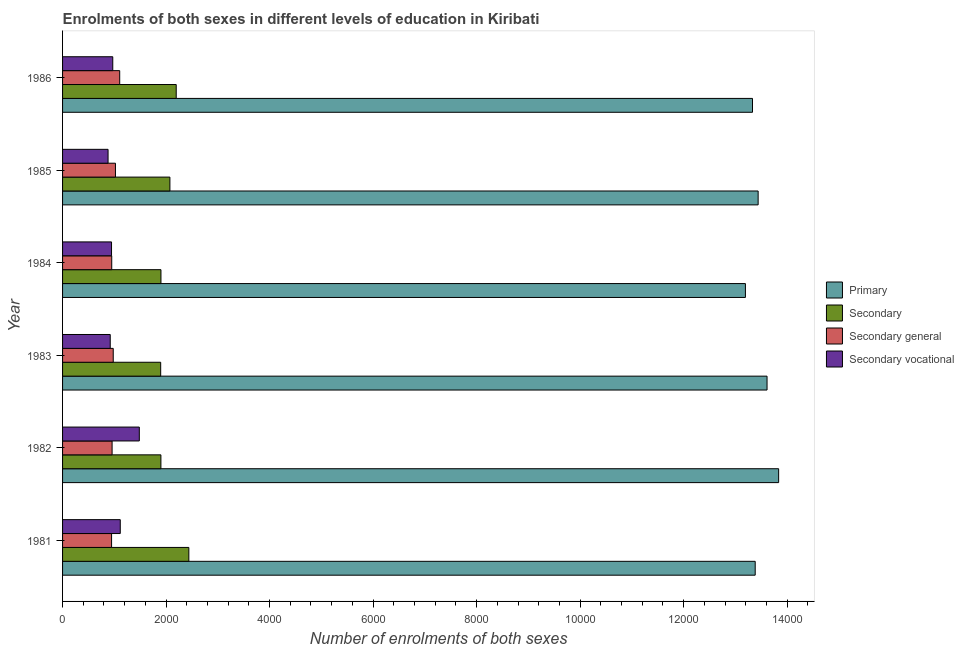How many different coloured bars are there?
Offer a very short reply. 4. How many bars are there on the 3rd tick from the bottom?
Ensure brevity in your answer.  4. In how many cases, is the number of bars for a given year not equal to the number of legend labels?
Your response must be concise. 0. What is the number of enrolments in secondary vocational education in 1981?
Your answer should be very brief. 1115. Across all years, what is the maximum number of enrolments in primary education?
Ensure brevity in your answer.  1.38e+04. Across all years, what is the minimum number of enrolments in secondary vocational education?
Provide a succinct answer. 879. What is the total number of enrolments in primary education in the graph?
Your answer should be very brief. 8.08e+04. What is the difference between the number of enrolments in secondary education in 1984 and that in 1985?
Your answer should be very brief. -173. What is the difference between the number of enrolments in primary education in 1982 and the number of enrolments in secondary education in 1986?
Offer a terse response. 1.16e+04. What is the average number of enrolments in secondary vocational education per year?
Your answer should be very brief. 1052.33. In the year 1986, what is the difference between the number of enrolments in primary education and number of enrolments in secondary education?
Make the answer very short. 1.11e+04. In how many years, is the number of enrolments in secondary education greater than 4400 ?
Your answer should be very brief. 0. What is the ratio of the number of enrolments in secondary education in 1985 to that in 1986?
Provide a succinct answer. 0.94. Is the number of enrolments in secondary education in 1984 less than that in 1986?
Keep it short and to the point. Yes. Is the difference between the number of enrolments in secondary general education in 1983 and 1985 greater than the difference between the number of enrolments in secondary education in 1983 and 1985?
Offer a terse response. Yes. What is the difference between the highest and the second highest number of enrolments in secondary education?
Offer a very short reply. 244. What is the difference between the highest and the lowest number of enrolments in secondary education?
Ensure brevity in your answer.  544. Is the sum of the number of enrolments in primary education in 1982 and 1984 greater than the maximum number of enrolments in secondary vocational education across all years?
Make the answer very short. Yes. Is it the case that in every year, the sum of the number of enrolments in secondary vocational education and number of enrolments in primary education is greater than the sum of number of enrolments in secondary education and number of enrolments in secondary general education?
Your answer should be very brief. Yes. What does the 3rd bar from the top in 1983 represents?
Provide a succinct answer. Secondary. What does the 3rd bar from the bottom in 1986 represents?
Your answer should be compact. Secondary general. How many years are there in the graph?
Offer a very short reply. 6. What is the difference between two consecutive major ticks on the X-axis?
Provide a succinct answer. 2000. What is the title of the graph?
Your answer should be very brief. Enrolments of both sexes in different levels of education in Kiribati. Does "Corruption" appear as one of the legend labels in the graph?
Ensure brevity in your answer.  No. What is the label or title of the X-axis?
Your answer should be compact. Number of enrolments of both sexes. What is the Number of enrolments of both sexes of Primary in 1981?
Ensure brevity in your answer.  1.34e+04. What is the Number of enrolments of both sexes of Secondary in 1981?
Make the answer very short. 2440. What is the Number of enrolments of both sexes in Secondary general in 1981?
Offer a very short reply. 947. What is the Number of enrolments of both sexes in Secondary vocational in 1981?
Provide a short and direct response. 1115. What is the Number of enrolments of both sexes of Primary in 1982?
Provide a succinct answer. 1.38e+04. What is the Number of enrolments of both sexes of Secondary in 1982?
Your answer should be very brief. 1900. What is the Number of enrolments of both sexes of Secondary general in 1982?
Provide a succinct answer. 957. What is the Number of enrolments of both sexes in Secondary vocational in 1982?
Offer a terse response. 1483. What is the Number of enrolments of both sexes in Primary in 1983?
Make the answer very short. 1.36e+04. What is the Number of enrolments of both sexes of Secondary in 1983?
Your answer should be very brief. 1896. What is the Number of enrolments of both sexes in Secondary general in 1983?
Your response must be concise. 979. What is the Number of enrolments of both sexes of Secondary vocational in 1983?
Your answer should be compact. 921. What is the Number of enrolments of both sexes of Primary in 1984?
Your response must be concise. 1.32e+04. What is the Number of enrolments of both sexes in Secondary in 1984?
Keep it short and to the point. 1901. What is the Number of enrolments of both sexes in Secondary general in 1984?
Offer a terse response. 950. What is the Number of enrolments of both sexes of Secondary vocational in 1984?
Provide a short and direct response. 946. What is the Number of enrolments of both sexes in Primary in 1985?
Provide a succinct answer. 1.34e+04. What is the Number of enrolments of both sexes in Secondary in 1985?
Offer a terse response. 2074. What is the Number of enrolments of both sexes of Secondary general in 1985?
Offer a terse response. 1022. What is the Number of enrolments of both sexes in Secondary vocational in 1985?
Give a very brief answer. 879. What is the Number of enrolments of both sexes of Primary in 1986?
Give a very brief answer. 1.33e+04. What is the Number of enrolments of both sexes of Secondary in 1986?
Provide a short and direct response. 2196. What is the Number of enrolments of both sexes of Secondary general in 1986?
Ensure brevity in your answer.  1104. What is the Number of enrolments of both sexes in Secondary vocational in 1986?
Keep it short and to the point. 970. Across all years, what is the maximum Number of enrolments of both sexes in Primary?
Your response must be concise. 1.38e+04. Across all years, what is the maximum Number of enrolments of both sexes of Secondary?
Offer a very short reply. 2440. Across all years, what is the maximum Number of enrolments of both sexes of Secondary general?
Offer a very short reply. 1104. Across all years, what is the maximum Number of enrolments of both sexes in Secondary vocational?
Keep it short and to the point. 1483. Across all years, what is the minimum Number of enrolments of both sexes in Primary?
Keep it short and to the point. 1.32e+04. Across all years, what is the minimum Number of enrolments of both sexes of Secondary?
Keep it short and to the point. 1896. Across all years, what is the minimum Number of enrolments of both sexes in Secondary general?
Give a very brief answer. 947. Across all years, what is the minimum Number of enrolments of both sexes of Secondary vocational?
Provide a short and direct response. 879. What is the total Number of enrolments of both sexes of Primary in the graph?
Ensure brevity in your answer.  8.08e+04. What is the total Number of enrolments of both sexes of Secondary in the graph?
Your response must be concise. 1.24e+04. What is the total Number of enrolments of both sexes in Secondary general in the graph?
Your response must be concise. 5959. What is the total Number of enrolments of both sexes of Secondary vocational in the graph?
Your response must be concise. 6314. What is the difference between the Number of enrolments of both sexes of Primary in 1981 and that in 1982?
Make the answer very short. -453. What is the difference between the Number of enrolments of both sexes in Secondary in 1981 and that in 1982?
Your answer should be very brief. 540. What is the difference between the Number of enrolments of both sexes in Secondary general in 1981 and that in 1982?
Offer a very short reply. -10. What is the difference between the Number of enrolments of both sexes of Secondary vocational in 1981 and that in 1982?
Provide a short and direct response. -368. What is the difference between the Number of enrolments of both sexes in Primary in 1981 and that in 1983?
Ensure brevity in your answer.  -229. What is the difference between the Number of enrolments of both sexes of Secondary in 1981 and that in 1983?
Offer a very short reply. 544. What is the difference between the Number of enrolments of both sexes of Secondary general in 1981 and that in 1983?
Offer a terse response. -32. What is the difference between the Number of enrolments of both sexes of Secondary vocational in 1981 and that in 1983?
Give a very brief answer. 194. What is the difference between the Number of enrolments of both sexes in Primary in 1981 and that in 1984?
Make the answer very short. 189. What is the difference between the Number of enrolments of both sexes of Secondary in 1981 and that in 1984?
Provide a succinct answer. 539. What is the difference between the Number of enrolments of both sexes of Secondary general in 1981 and that in 1984?
Your response must be concise. -3. What is the difference between the Number of enrolments of both sexes of Secondary vocational in 1981 and that in 1984?
Provide a succinct answer. 169. What is the difference between the Number of enrolments of both sexes of Primary in 1981 and that in 1985?
Your answer should be very brief. -57. What is the difference between the Number of enrolments of both sexes in Secondary in 1981 and that in 1985?
Give a very brief answer. 366. What is the difference between the Number of enrolments of both sexes of Secondary general in 1981 and that in 1985?
Provide a succinct answer. -75. What is the difference between the Number of enrolments of both sexes of Secondary vocational in 1981 and that in 1985?
Give a very brief answer. 236. What is the difference between the Number of enrolments of both sexes of Primary in 1981 and that in 1986?
Make the answer very short. 52. What is the difference between the Number of enrolments of both sexes in Secondary in 1981 and that in 1986?
Make the answer very short. 244. What is the difference between the Number of enrolments of both sexes of Secondary general in 1981 and that in 1986?
Your answer should be compact. -157. What is the difference between the Number of enrolments of both sexes of Secondary vocational in 1981 and that in 1986?
Give a very brief answer. 145. What is the difference between the Number of enrolments of both sexes of Primary in 1982 and that in 1983?
Your answer should be very brief. 224. What is the difference between the Number of enrolments of both sexes of Secondary general in 1982 and that in 1983?
Provide a short and direct response. -22. What is the difference between the Number of enrolments of both sexes in Secondary vocational in 1982 and that in 1983?
Offer a terse response. 562. What is the difference between the Number of enrolments of both sexes of Primary in 1982 and that in 1984?
Give a very brief answer. 642. What is the difference between the Number of enrolments of both sexes in Secondary vocational in 1982 and that in 1984?
Give a very brief answer. 537. What is the difference between the Number of enrolments of both sexes of Primary in 1982 and that in 1985?
Offer a very short reply. 396. What is the difference between the Number of enrolments of both sexes of Secondary in 1982 and that in 1985?
Ensure brevity in your answer.  -174. What is the difference between the Number of enrolments of both sexes of Secondary general in 1982 and that in 1985?
Make the answer very short. -65. What is the difference between the Number of enrolments of both sexes of Secondary vocational in 1982 and that in 1985?
Keep it short and to the point. 604. What is the difference between the Number of enrolments of both sexes of Primary in 1982 and that in 1986?
Ensure brevity in your answer.  505. What is the difference between the Number of enrolments of both sexes of Secondary in 1982 and that in 1986?
Your answer should be compact. -296. What is the difference between the Number of enrolments of both sexes in Secondary general in 1982 and that in 1986?
Keep it short and to the point. -147. What is the difference between the Number of enrolments of both sexes of Secondary vocational in 1982 and that in 1986?
Ensure brevity in your answer.  513. What is the difference between the Number of enrolments of both sexes of Primary in 1983 and that in 1984?
Make the answer very short. 418. What is the difference between the Number of enrolments of both sexes of Secondary in 1983 and that in 1984?
Give a very brief answer. -5. What is the difference between the Number of enrolments of both sexes in Secondary vocational in 1983 and that in 1984?
Provide a succinct answer. -25. What is the difference between the Number of enrolments of both sexes of Primary in 1983 and that in 1985?
Ensure brevity in your answer.  172. What is the difference between the Number of enrolments of both sexes in Secondary in 1983 and that in 1985?
Offer a very short reply. -178. What is the difference between the Number of enrolments of both sexes in Secondary general in 1983 and that in 1985?
Ensure brevity in your answer.  -43. What is the difference between the Number of enrolments of both sexes in Primary in 1983 and that in 1986?
Provide a short and direct response. 281. What is the difference between the Number of enrolments of both sexes of Secondary in 1983 and that in 1986?
Offer a terse response. -300. What is the difference between the Number of enrolments of both sexes in Secondary general in 1983 and that in 1986?
Offer a very short reply. -125. What is the difference between the Number of enrolments of both sexes in Secondary vocational in 1983 and that in 1986?
Your response must be concise. -49. What is the difference between the Number of enrolments of both sexes of Primary in 1984 and that in 1985?
Offer a terse response. -246. What is the difference between the Number of enrolments of both sexes of Secondary in 1984 and that in 1985?
Provide a succinct answer. -173. What is the difference between the Number of enrolments of both sexes of Secondary general in 1984 and that in 1985?
Offer a terse response. -72. What is the difference between the Number of enrolments of both sexes in Primary in 1984 and that in 1986?
Provide a succinct answer. -137. What is the difference between the Number of enrolments of both sexes in Secondary in 1984 and that in 1986?
Offer a terse response. -295. What is the difference between the Number of enrolments of both sexes of Secondary general in 1984 and that in 1986?
Keep it short and to the point. -154. What is the difference between the Number of enrolments of both sexes of Secondary vocational in 1984 and that in 1986?
Make the answer very short. -24. What is the difference between the Number of enrolments of both sexes of Primary in 1985 and that in 1986?
Your answer should be very brief. 109. What is the difference between the Number of enrolments of both sexes in Secondary in 1985 and that in 1986?
Your answer should be very brief. -122. What is the difference between the Number of enrolments of both sexes in Secondary general in 1985 and that in 1986?
Make the answer very short. -82. What is the difference between the Number of enrolments of both sexes in Secondary vocational in 1985 and that in 1986?
Your answer should be compact. -91. What is the difference between the Number of enrolments of both sexes of Primary in 1981 and the Number of enrolments of both sexes of Secondary in 1982?
Your response must be concise. 1.15e+04. What is the difference between the Number of enrolments of both sexes in Primary in 1981 and the Number of enrolments of both sexes in Secondary general in 1982?
Offer a very short reply. 1.24e+04. What is the difference between the Number of enrolments of both sexes of Primary in 1981 and the Number of enrolments of both sexes of Secondary vocational in 1982?
Provide a short and direct response. 1.19e+04. What is the difference between the Number of enrolments of both sexes of Secondary in 1981 and the Number of enrolments of both sexes of Secondary general in 1982?
Your answer should be compact. 1483. What is the difference between the Number of enrolments of both sexes of Secondary in 1981 and the Number of enrolments of both sexes of Secondary vocational in 1982?
Provide a short and direct response. 957. What is the difference between the Number of enrolments of both sexes of Secondary general in 1981 and the Number of enrolments of both sexes of Secondary vocational in 1982?
Keep it short and to the point. -536. What is the difference between the Number of enrolments of both sexes in Primary in 1981 and the Number of enrolments of both sexes in Secondary in 1983?
Your answer should be very brief. 1.15e+04. What is the difference between the Number of enrolments of both sexes of Primary in 1981 and the Number of enrolments of both sexes of Secondary general in 1983?
Offer a terse response. 1.24e+04. What is the difference between the Number of enrolments of both sexes of Primary in 1981 and the Number of enrolments of both sexes of Secondary vocational in 1983?
Give a very brief answer. 1.25e+04. What is the difference between the Number of enrolments of both sexes of Secondary in 1981 and the Number of enrolments of both sexes of Secondary general in 1983?
Give a very brief answer. 1461. What is the difference between the Number of enrolments of both sexes of Secondary in 1981 and the Number of enrolments of both sexes of Secondary vocational in 1983?
Make the answer very short. 1519. What is the difference between the Number of enrolments of both sexes of Secondary general in 1981 and the Number of enrolments of both sexes of Secondary vocational in 1983?
Make the answer very short. 26. What is the difference between the Number of enrolments of both sexes of Primary in 1981 and the Number of enrolments of both sexes of Secondary in 1984?
Offer a very short reply. 1.15e+04. What is the difference between the Number of enrolments of both sexes in Primary in 1981 and the Number of enrolments of both sexes in Secondary general in 1984?
Provide a short and direct response. 1.24e+04. What is the difference between the Number of enrolments of both sexes in Primary in 1981 and the Number of enrolments of both sexes in Secondary vocational in 1984?
Provide a succinct answer. 1.24e+04. What is the difference between the Number of enrolments of both sexes in Secondary in 1981 and the Number of enrolments of both sexes in Secondary general in 1984?
Offer a very short reply. 1490. What is the difference between the Number of enrolments of both sexes of Secondary in 1981 and the Number of enrolments of both sexes of Secondary vocational in 1984?
Your response must be concise. 1494. What is the difference between the Number of enrolments of both sexes in Secondary general in 1981 and the Number of enrolments of both sexes in Secondary vocational in 1984?
Keep it short and to the point. 1. What is the difference between the Number of enrolments of both sexes in Primary in 1981 and the Number of enrolments of both sexes in Secondary in 1985?
Your answer should be compact. 1.13e+04. What is the difference between the Number of enrolments of both sexes of Primary in 1981 and the Number of enrolments of both sexes of Secondary general in 1985?
Your answer should be very brief. 1.24e+04. What is the difference between the Number of enrolments of both sexes in Primary in 1981 and the Number of enrolments of both sexes in Secondary vocational in 1985?
Offer a terse response. 1.25e+04. What is the difference between the Number of enrolments of both sexes in Secondary in 1981 and the Number of enrolments of both sexes in Secondary general in 1985?
Keep it short and to the point. 1418. What is the difference between the Number of enrolments of both sexes in Secondary in 1981 and the Number of enrolments of both sexes in Secondary vocational in 1985?
Make the answer very short. 1561. What is the difference between the Number of enrolments of both sexes of Primary in 1981 and the Number of enrolments of both sexes of Secondary in 1986?
Provide a short and direct response. 1.12e+04. What is the difference between the Number of enrolments of both sexes in Primary in 1981 and the Number of enrolments of both sexes in Secondary general in 1986?
Give a very brief answer. 1.23e+04. What is the difference between the Number of enrolments of both sexes of Primary in 1981 and the Number of enrolments of both sexes of Secondary vocational in 1986?
Your response must be concise. 1.24e+04. What is the difference between the Number of enrolments of both sexes of Secondary in 1981 and the Number of enrolments of both sexes of Secondary general in 1986?
Offer a very short reply. 1336. What is the difference between the Number of enrolments of both sexes in Secondary in 1981 and the Number of enrolments of both sexes in Secondary vocational in 1986?
Keep it short and to the point. 1470. What is the difference between the Number of enrolments of both sexes of Primary in 1982 and the Number of enrolments of both sexes of Secondary in 1983?
Provide a short and direct response. 1.19e+04. What is the difference between the Number of enrolments of both sexes in Primary in 1982 and the Number of enrolments of both sexes in Secondary general in 1983?
Make the answer very short. 1.29e+04. What is the difference between the Number of enrolments of both sexes in Primary in 1982 and the Number of enrolments of both sexes in Secondary vocational in 1983?
Keep it short and to the point. 1.29e+04. What is the difference between the Number of enrolments of both sexes of Secondary in 1982 and the Number of enrolments of both sexes of Secondary general in 1983?
Ensure brevity in your answer.  921. What is the difference between the Number of enrolments of both sexes in Secondary in 1982 and the Number of enrolments of both sexes in Secondary vocational in 1983?
Offer a terse response. 979. What is the difference between the Number of enrolments of both sexes of Primary in 1982 and the Number of enrolments of both sexes of Secondary in 1984?
Keep it short and to the point. 1.19e+04. What is the difference between the Number of enrolments of both sexes in Primary in 1982 and the Number of enrolments of both sexes in Secondary general in 1984?
Provide a succinct answer. 1.29e+04. What is the difference between the Number of enrolments of both sexes in Primary in 1982 and the Number of enrolments of both sexes in Secondary vocational in 1984?
Provide a succinct answer. 1.29e+04. What is the difference between the Number of enrolments of both sexes in Secondary in 1982 and the Number of enrolments of both sexes in Secondary general in 1984?
Give a very brief answer. 950. What is the difference between the Number of enrolments of both sexes in Secondary in 1982 and the Number of enrolments of both sexes in Secondary vocational in 1984?
Make the answer very short. 954. What is the difference between the Number of enrolments of both sexes in Secondary general in 1982 and the Number of enrolments of both sexes in Secondary vocational in 1984?
Offer a terse response. 11. What is the difference between the Number of enrolments of both sexes of Primary in 1982 and the Number of enrolments of both sexes of Secondary in 1985?
Offer a very short reply. 1.18e+04. What is the difference between the Number of enrolments of both sexes of Primary in 1982 and the Number of enrolments of both sexes of Secondary general in 1985?
Offer a very short reply. 1.28e+04. What is the difference between the Number of enrolments of both sexes of Primary in 1982 and the Number of enrolments of both sexes of Secondary vocational in 1985?
Ensure brevity in your answer.  1.30e+04. What is the difference between the Number of enrolments of both sexes in Secondary in 1982 and the Number of enrolments of both sexes in Secondary general in 1985?
Ensure brevity in your answer.  878. What is the difference between the Number of enrolments of both sexes in Secondary in 1982 and the Number of enrolments of both sexes in Secondary vocational in 1985?
Your answer should be very brief. 1021. What is the difference between the Number of enrolments of both sexes of Secondary general in 1982 and the Number of enrolments of both sexes of Secondary vocational in 1985?
Your answer should be compact. 78. What is the difference between the Number of enrolments of both sexes in Primary in 1982 and the Number of enrolments of both sexes in Secondary in 1986?
Keep it short and to the point. 1.16e+04. What is the difference between the Number of enrolments of both sexes in Primary in 1982 and the Number of enrolments of both sexes in Secondary general in 1986?
Your response must be concise. 1.27e+04. What is the difference between the Number of enrolments of both sexes in Primary in 1982 and the Number of enrolments of both sexes in Secondary vocational in 1986?
Your answer should be compact. 1.29e+04. What is the difference between the Number of enrolments of both sexes in Secondary in 1982 and the Number of enrolments of both sexes in Secondary general in 1986?
Ensure brevity in your answer.  796. What is the difference between the Number of enrolments of both sexes in Secondary in 1982 and the Number of enrolments of both sexes in Secondary vocational in 1986?
Give a very brief answer. 930. What is the difference between the Number of enrolments of both sexes in Primary in 1983 and the Number of enrolments of both sexes in Secondary in 1984?
Keep it short and to the point. 1.17e+04. What is the difference between the Number of enrolments of both sexes of Primary in 1983 and the Number of enrolments of both sexes of Secondary general in 1984?
Provide a succinct answer. 1.27e+04. What is the difference between the Number of enrolments of both sexes in Primary in 1983 and the Number of enrolments of both sexes in Secondary vocational in 1984?
Provide a short and direct response. 1.27e+04. What is the difference between the Number of enrolments of both sexes of Secondary in 1983 and the Number of enrolments of both sexes of Secondary general in 1984?
Give a very brief answer. 946. What is the difference between the Number of enrolments of both sexes of Secondary in 1983 and the Number of enrolments of both sexes of Secondary vocational in 1984?
Keep it short and to the point. 950. What is the difference between the Number of enrolments of both sexes in Secondary general in 1983 and the Number of enrolments of both sexes in Secondary vocational in 1984?
Keep it short and to the point. 33. What is the difference between the Number of enrolments of both sexes of Primary in 1983 and the Number of enrolments of both sexes of Secondary in 1985?
Offer a terse response. 1.15e+04. What is the difference between the Number of enrolments of both sexes in Primary in 1983 and the Number of enrolments of both sexes in Secondary general in 1985?
Ensure brevity in your answer.  1.26e+04. What is the difference between the Number of enrolments of both sexes of Primary in 1983 and the Number of enrolments of both sexes of Secondary vocational in 1985?
Provide a succinct answer. 1.27e+04. What is the difference between the Number of enrolments of both sexes in Secondary in 1983 and the Number of enrolments of both sexes in Secondary general in 1985?
Provide a short and direct response. 874. What is the difference between the Number of enrolments of both sexes of Secondary in 1983 and the Number of enrolments of both sexes of Secondary vocational in 1985?
Your answer should be very brief. 1017. What is the difference between the Number of enrolments of both sexes of Secondary general in 1983 and the Number of enrolments of both sexes of Secondary vocational in 1985?
Ensure brevity in your answer.  100. What is the difference between the Number of enrolments of both sexes in Primary in 1983 and the Number of enrolments of both sexes in Secondary in 1986?
Your response must be concise. 1.14e+04. What is the difference between the Number of enrolments of both sexes in Primary in 1983 and the Number of enrolments of both sexes in Secondary general in 1986?
Provide a short and direct response. 1.25e+04. What is the difference between the Number of enrolments of both sexes in Primary in 1983 and the Number of enrolments of both sexes in Secondary vocational in 1986?
Keep it short and to the point. 1.26e+04. What is the difference between the Number of enrolments of both sexes of Secondary in 1983 and the Number of enrolments of both sexes of Secondary general in 1986?
Ensure brevity in your answer.  792. What is the difference between the Number of enrolments of both sexes of Secondary in 1983 and the Number of enrolments of both sexes of Secondary vocational in 1986?
Provide a succinct answer. 926. What is the difference between the Number of enrolments of both sexes in Secondary general in 1983 and the Number of enrolments of both sexes in Secondary vocational in 1986?
Offer a terse response. 9. What is the difference between the Number of enrolments of both sexes of Primary in 1984 and the Number of enrolments of both sexes of Secondary in 1985?
Your answer should be compact. 1.11e+04. What is the difference between the Number of enrolments of both sexes of Primary in 1984 and the Number of enrolments of both sexes of Secondary general in 1985?
Offer a terse response. 1.22e+04. What is the difference between the Number of enrolments of both sexes of Primary in 1984 and the Number of enrolments of both sexes of Secondary vocational in 1985?
Offer a terse response. 1.23e+04. What is the difference between the Number of enrolments of both sexes in Secondary in 1984 and the Number of enrolments of both sexes in Secondary general in 1985?
Ensure brevity in your answer.  879. What is the difference between the Number of enrolments of both sexes in Secondary in 1984 and the Number of enrolments of both sexes in Secondary vocational in 1985?
Offer a very short reply. 1022. What is the difference between the Number of enrolments of both sexes of Primary in 1984 and the Number of enrolments of both sexes of Secondary in 1986?
Ensure brevity in your answer.  1.10e+04. What is the difference between the Number of enrolments of both sexes in Primary in 1984 and the Number of enrolments of both sexes in Secondary general in 1986?
Your answer should be compact. 1.21e+04. What is the difference between the Number of enrolments of both sexes in Primary in 1984 and the Number of enrolments of both sexes in Secondary vocational in 1986?
Give a very brief answer. 1.22e+04. What is the difference between the Number of enrolments of both sexes in Secondary in 1984 and the Number of enrolments of both sexes in Secondary general in 1986?
Provide a succinct answer. 797. What is the difference between the Number of enrolments of both sexes of Secondary in 1984 and the Number of enrolments of both sexes of Secondary vocational in 1986?
Ensure brevity in your answer.  931. What is the difference between the Number of enrolments of both sexes in Secondary general in 1984 and the Number of enrolments of both sexes in Secondary vocational in 1986?
Keep it short and to the point. -20. What is the difference between the Number of enrolments of both sexes of Primary in 1985 and the Number of enrolments of both sexes of Secondary in 1986?
Offer a terse response. 1.12e+04. What is the difference between the Number of enrolments of both sexes in Primary in 1985 and the Number of enrolments of both sexes in Secondary general in 1986?
Your response must be concise. 1.23e+04. What is the difference between the Number of enrolments of both sexes in Primary in 1985 and the Number of enrolments of both sexes in Secondary vocational in 1986?
Offer a very short reply. 1.25e+04. What is the difference between the Number of enrolments of both sexes in Secondary in 1985 and the Number of enrolments of both sexes in Secondary general in 1986?
Offer a terse response. 970. What is the difference between the Number of enrolments of both sexes of Secondary in 1985 and the Number of enrolments of both sexes of Secondary vocational in 1986?
Your response must be concise. 1104. What is the average Number of enrolments of both sexes of Primary per year?
Offer a terse response. 1.35e+04. What is the average Number of enrolments of both sexes in Secondary per year?
Provide a succinct answer. 2067.83. What is the average Number of enrolments of both sexes in Secondary general per year?
Offer a very short reply. 993.17. What is the average Number of enrolments of both sexes in Secondary vocational per year?
Your answer should be compact. 1052.33. In the year 1981, what is the difference between the Number of enrolments of both sexes of Primary and Number of enrolments of both sexes of Secondary?
Your answer should be very brief. 1.09e+04. In the year 1981, what is the difference between the Number of enrolments of both sexes in Primary and Number of enrolments of both sexes in Secondary general?
Offer a terse response. 1.24e+04. In the year 1981, what is the difference between the Number of enrolments of both sexes of Primary and Number of enrolments of both sexes of Secondary vocational?
Ensure brevity in your answer.  1.23e+04. In the year 1981, what is the difference between the Number of enrolments of both sexes of Secondary and Number of enrolments of both sexes of Secondary general?
Offer a terse response. 1493. In the year 1981, what is the difference between the Number of enrolments of both sexes of Secondary and Number of enrolments of both sexes of Secondary vocational?
Keep it short and to the point. 1325. In the year 1981, what is the difference between the Number of enrolments of both sexes in Secondary general and Number of enrolments of both sexes in Secondary vocational?
Provide a succinct answer. -168. In the year 1982, what is the difference between the Number of enrolments of both sexes of Primary and Number of enrolments of both sexes of Secondary?
Provide a short and direct response. 1.19e+04. In the year 1982, what is the difference between the Number of enrolments of both sexes of Primary and Number of enrolments of both sexes of Secondary general?
Provide a succinct answer. 1.29e+04. In the year 1982, what is the difference between the Number of enrolments of both sexes in Primary and Number of enrolments of both sexes in Secondary vocational?
Your response must be concise. 1.24e+04. In the year 1982, what is the difference between the Number of enrolments of both sexes in Secondary and Number of enrolments of both sexes in Secondary general?
Ensure brevity in your answer.  943. In the year 1982, what is the difference between the Number of enrolments of both sexes of Secondary and Number of enrolments of both sexes of Secondary vocational?
Your answer should be very brief. 417. In the year 1982, what is the difference between the Number of enrolments of both sexes of Secondary general and Number of enrolments of both sexes of Secondary vocational?
Make the answer very short. -526. In the year 1983, what is the difference between the Number of enrolments of both sexes in Primary and Number of enrolments of both sexes in Secondary?
Provide a short and direct response. 1.17e+04. In the year 1983, what is the difference between the Number of enrolments of both sexes of Primary and Number of enrolments of both sexes of Secondary general?
Ensure brevity in your answer.  1.26e+04. In the year 1983, what is the difference between the Number of enrolments of both sexes of Primary and Number of enrolments of both sexes of Secondary vocational?
Your answer should be very brief. 1.27e+04. In the year 1983, what is the difference between the Number of enrolments of both sexes in Secondary and Number of enrolments of both sexes in Secondary general?
Give a very brief answer. 917. In the year 1983, what is the difference between the Number of enrolments of both sexes of Secondary and Number of enrolments of both sexes of Secondary vocational?
Your answer should be very brief. 975. In the year 1983, what is the difference between the Number of enrolments of both sexes of Secondary general and Number of enrolments of both sexes of Secondary vocational?
Make the answer very short. 58. In the year 1984, what is the difference between the Number of enrolments of both sexes of Primary and Number of enrolments of both sexes of Secondary?
Offer a terse response. 1.13e+04. In the year 1984, what is the difference between the Number of enrolments of both sexes of Primary and Number of enrolments of both sexes of Secondary general?
Offer a terse response. 1.22e+04. In the year 1984, what is the difference between the Number of enrolments of both sexes of Primary and Number of enrolments of both sexes of Secondary vocational?
Provide a succinct answer. 1.22e+04. In the year 1984, what is the difference between the Number of enrolments of both sexes of Secondary and Number of enrolments of both sexes of Secondary general?
Your response must be concise. 951. In the year 1984, what is the difference between the Number of enrolments of both sexes in Secondary and Number of enrolments of both sexes in Secondary vocational?
Your answer should be very brief. 955. In the year 1985, what is the difference between the Number of enrolments of both sexes in Primary and Number of enrolments of both sexes in Secondary?
Your answer should be compact. 1.14e+04. In the year 1985, what is the difference between the Number of enrolments of both sexes of Primary and Number of enrolments of both sexes of Secondary general?
Your answer should be very brief. 1.24e+04. In the year 1985, what is the difference between the Number of enrolments of both sexes of Primary and Number of enrolments of both sexes of Secondary vocational?
Ensure brevity in your answer.  1.26e+04. In the year 1985, what is the difference between the Number of enrolments of both sexes in Secondary and Number of enrolments of both sexes in Secondary general?
Make the answer very short. 1052. In the year 1985, what is the difference between the Number of enrolments of both sexes in Secondary and Number of enrolments of both sexes in Secondary vocational?
Provide a succinct answer. 1195. In the year 1985, what is the difference between the Number of enrolments of both sexes of Secondary general and Number of enrolments of both sexes of Secondary vocational?
Offer a very short reply. 143. In the year 1986, what is the difference between the Number of enrolments of both sexes of Primary and Number of enrolments of both sexes of Secondary?
Offer a terse response. 1.11e+04. In the year 1986, what is the difference between the Number of enrolments of both sexes of Primary and Number of enrolments of both sexes of Secondary general?
Provide a succinct answer. 1.22e+04. In the year 1986, what is the difference between the Number of enrolments of both sexes of Primary and Number of enrolments of both sexes of Secondary vocational?
Give a very brief answer. 1.24e+04. In the year 1986, what is the difference between the Number of enrolments of both sexes of Secondary and Number of enrolments of both sexes of Secondary general?
Provide a succinct answer. 1092. In the year 1986, what is the difference between the Number of enrolments of both sexes in Secondary and Number of enrolments of both sexes in Secondary vocational?
Provide a succinct answer. 1226. In the year 1986, what is the difference between the Number of enrolments of both sexes of Secondary general and Number of enrolments of both sexes of Secondary vocational?
Provide a succinct answer. 134. What is the ratio of the Number of enrolments of both sexes of Primary in 1981 to that in 1982?
Ensure brevity in your answer.  0.97. What is the ratio of the Number of enrolments of both sexes in Secondary in 1981 to that in 1982?
Keep it short and to the point. 1.28. What is the ratio of the Number of enrolments of both sexes of Secondary vocational in 1981 to that in 1982?
Your answer should be compact. 0.75. What is the ratio of the Number of enrolments of both sexes of Primary in 1981 to that in 1983?
Offer a terse response. 0.98. What is the ratio of the Number of enrolments of both sexes in Secondary in 1981 to that in 1983?
Your answer should be very brief. 1.29. What is the ratio of the Number of enrolments of both sexes in Secondary general in 1981 to that in 1983?
Your response must be concise. 0.97. What is the ratio of the Number of enrolments of both sexes in Secondary vocational in 1981 to that in 1983?
Keep it short and to the point. 1.21. What is the ratio of the Number of enrolments of both sexes in Primary in 1981 to that in 1984?
Make the answer very short. 1.01. What is the ratio of the Number of enrolments of both sexes of Secondary in 1981 to that in 1984?
Keep it short and to the point. 1.28. What is the ratio of the Number of enrolments of both sexes of Secondary vocational in 1981 to that in 1984?
Ensure brevity in your answer.  1.18. What is the ratio of the Number of enrolments of both sexes in Secondary in 1981 to that in 1985?
Provide a short and direct response. 1.18. What is the ratio of the Number of enrolments of both sexes in Secondary general in 1981 to that in 1985?
Ensure brevity in your answer.  0.93. What is the ratio of the Number of enrolments of both sexes in Secondary vocational in 1981 to that in 1985?
Keep it short and to the point. 1.27. What is the ratio of the Number of enrolments of both sexes in Secondary in 1981 to that in 1986?
Provide a short and direct response. 1.11. What is the ratio of the Number of enrolments of both sexes in Secondary general in 1981 to that in 1986?
Ensure brevity in your answer.  0.86. What is the ratio of the Number of enrolments of both sexes of Secondary vocational in 1981 to that in 1986?
Your answer should be very brief. 1.15. What is the ratio of the Number of enrolments of both sexes of Primary in 1982 to that in 1983?
Offer a very short reply. 1.02. What is the ratio of the Number of enrolments of both sexes in Secondary general in 1982 to that in 1983?
Your answer should be very brief. 0.98. What is the ratio of the Number of enrolments of both sexes in Secondary vocational in 1982 to that in 1983?
Make the answer very short. 1.61. What is the ratio of the Number of enrolments of both sexes in Primary in 1982 to that in 1984?
Provide a short and direct response. 1.05. What is the ratio of the Number of enrolments of both sexes in Secondary in 1982 to that in 1984?
Provide a succinct answer. 1. What is the ratio of the Number of enrolments of both sexes in Secondary general in 1982 to that in 1984?
Make the answer very short. 1.01. What is the ratio of the Number of enrolments of both sexes in Secondary vocational in 1982 to that in 1984?
Offer a terse response. 1.57. What is the ratio of the Number of enrolments of both sexes in Primary in 1982 to that in 1985?
Provide a succinct answer. 1.03. What is the ratio of the Number of enrolments of both sexes in Secondary in 1982 to that in 1985?
Give a very brief answer. 0.92. What is the ratio of the Number of enrolments of both sexes in Secondary general in 1982 to that in 1985?
Provide a short and direct response. 0.94. What is the ratio of the Number of enrolments of both sexes of Secondary vocational in 1982 to that in 1985?
Your response must be concise. 1.69. What is the ratio of the Number of enrolments of both sexes in Primary in 1982 to that in 1986?
Your answer should be very brief. 1.04. What is the ratio of the Number of enrolments of both sexes in Secondary in 1982 to that in 1986?
Your answer should be compact. 0.87. What is the ratio of the Number of enrolments of both sexes of Secondary general in 1982 to that in 1986?
Provide a succinct answer. 0.87. What is the ratio of the Number of enrolments of both sexes in Secondary vocational in 1982 to that in 1986?
Offer a terse response. 1.53. What is the ratio of the Number of enrolments of both sexes of Primary in 1983 to that in 1984?
Provide a short and direct response. 1.03. What is the ratio of the Number of enrolments of both sexes in Secondary general in 1983 to that in 1984?
Make the answer very short. 1.03. What is the ratio of the Number of enrolments of both sexes of Secondary vocational in 1983 to that in 1984?
Make the answer very short. 0.97. What is the ratio of the Number of enrolments of both sexes of Primary in 1983 to that in 1985?
Provide a short and direct response. 1.01. What is the ratio of the Number of enrolments of both sexes of Secondary in 1983 to that in 1985?
Your response must be concise. 0.91. What is the ratio of the Number of enrolments of both sexes of Secondary general in 1983 to that in 1985?
Give a very brief answer. 0.96. What is the ratio of the Number of enrolments of both sexes of Secondary vocational in 1983 to that in 1985?
Your answer should be very brief. 1.05. What is the ratio of the Number of enrolments of both sexes of Primary in 1983 to that in 1986?
Provide a succinct answer. 1.02. What is the ratio of the Number of enrolments of both sexes in Secondary in 1983 to that in 1986?
Your answer should be compact. 0.86. What is the ratio of the Number of enrolments of both sexes of Secondary general in 1983 to that in 1986?
Ensure brevity in your answer.  0.89. What is the ratio of the Number of enrolments of both sexes in Secondary vocational in 1983 to that in 1986?
Keep it short and to the point. 0.95. What is the ratio of the Number of enrolments of both sexes in Primary in 1984 to that in 1985?
Provide a succinct answer. 0.98. What is the ratio of the Number of enrolments of both sexes in Secondary in 1984 to that in 1985?
Your answer should be compact. 0.92. What is the ratio of the Number of enrolments of both sexes of Secondary general in 1984 to that in 1985?
Your answer should be very brief. 0.93. What is the ratio of the Number of enrolments of both sexes in Secondary vocational in 1984 to that in 1985?
Make the answer very short. 1.08. What is the ratio of the Number of enrolments of both sexes in Primary in 1984 to that in 1986?
Your answer should be compact. 0.99. What is the ratio of the Number of enrolments of both sexes of Secondary in 1984 to that in 1986?
Ensure brevity in your answer.  0.87. What is the ratio of the Number of enrolments of both sexes of Secondary general in 1984 to that in 1986?
Give a very brief answer. 0.86. What is the ratio of the Number of enrolments of both sexes in Secondary vocational in 1984 to that in 1986?
Ensure brevity in your answer.  0.98. What is the ratio of the Number of enrolments of both sexes of Primary in 1985 to that in 1986?
Provide a short and direct response. 1.01. What is the ratio of the Number of enrolments of both sexes of Secondary in 1985 to that in 1986?
Your response must be concise. 0.94. What is the ratio of the Number of enrolments of both sexes of Secondary general in 1985 to that in 1986?
Offer a very short reply. 0.93. What is the ratio of the Number of enrolments of both sexes in Secondary vocational in 1985 to that in 1986?
Provide a succinct answer. 0.91. What is the difference between the highest and the second highest Number of enrolments of both sexes in Primary?
Provide a short and direct response. 224. What is the difference between the highest and the second highest Number of enrolments of both sexes of Secondary?
Ensure brevity in your answer.  244. What is the difference between the highest and the second highest Number of enrolments of both sexes in Secondary vocational?
Provide a succinct answer. 368. What is the difference between the highest and the lowest Number of enrolments of both sexes of Primary?
Keep it short and to the point. 642. What is the difference between the highest and the lowest Number of enrolments of both sexes of Secondary?
Offer a terse response. 544. What is the difference between the highest and the lowest Number of enrolments of both sexes in Secondary general?
Provide a succinct answer. 157. What is the difference between the highest and the lowest Number of enrolments of both sexes in Secondary vocational?
Make the answer very short. 604. 